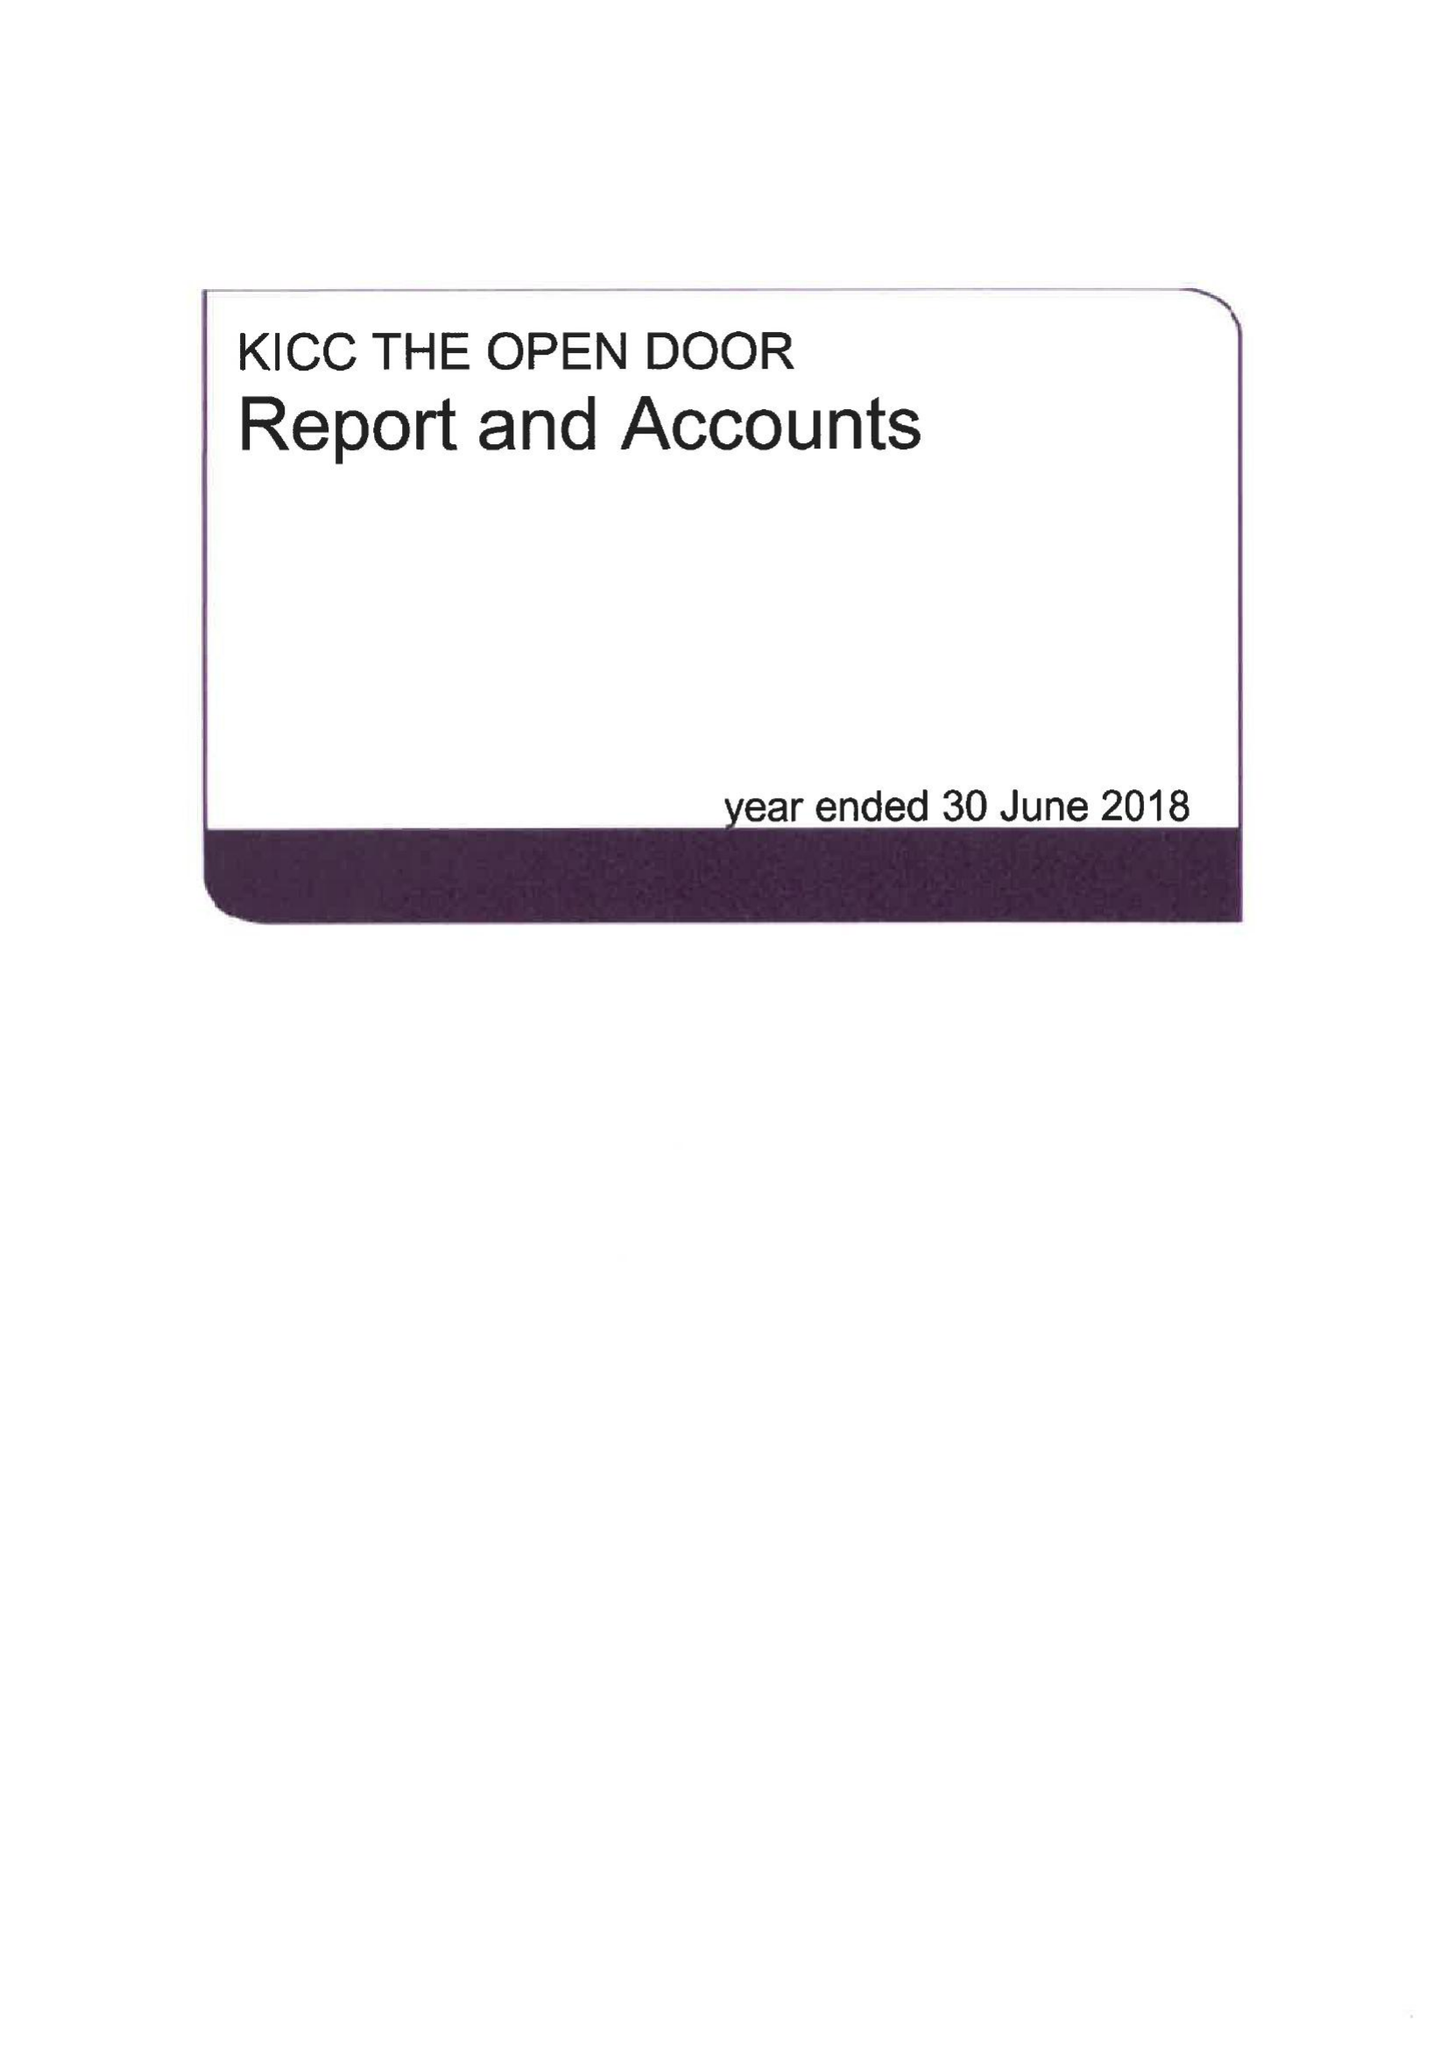What is the value for the report_date?
Answer the question using a single word or phrase. 2018-06-30 